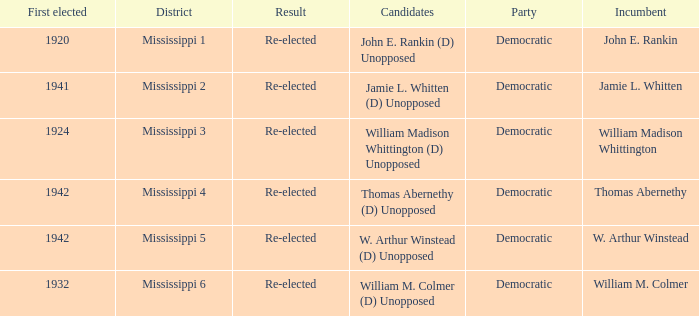Which district is jamie l. whitten from? Mississippi 2. 